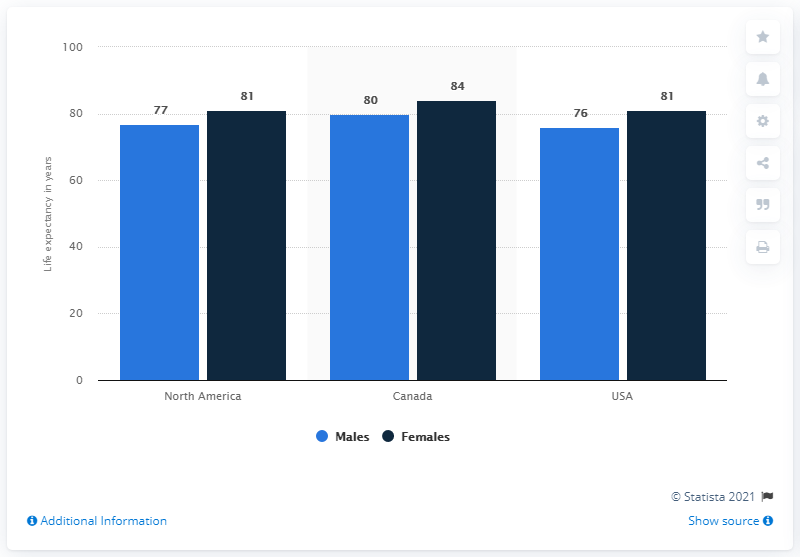Indicate a few pertinent items in this graphic. Canada has the tallest black bar. The difference in average life expectancy between females and males in a single country is the largest in [country name]. 